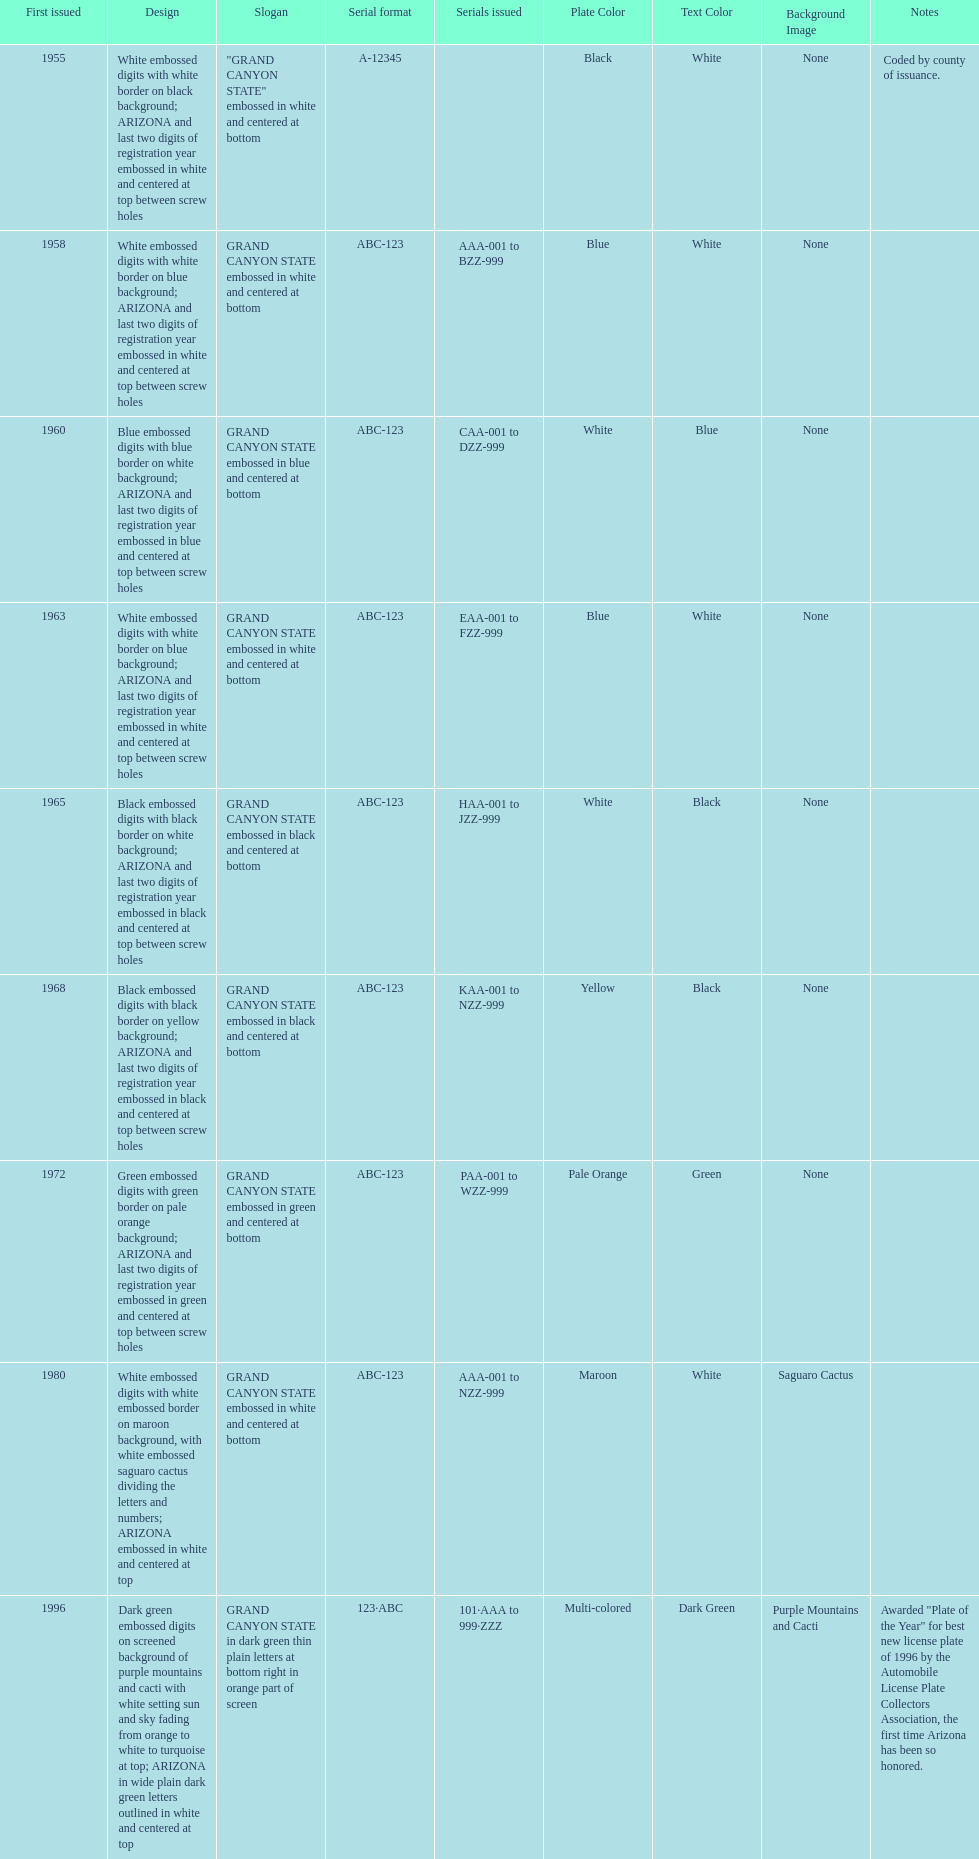Name the year of the license plate that has the largest amount of alphanumeric digits. 2008. 